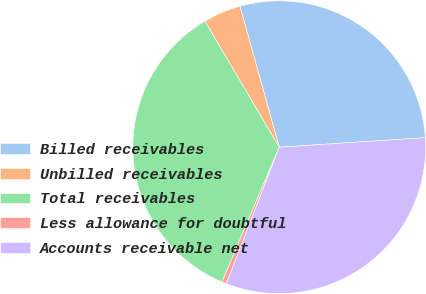Convert chart to OTSL. <chart><loc_0><loc_0><loc_500><loc_500><pie_chart><fcel>Billed receivables<fcel>Unbilled receivables<fcel>Total receivables<fcel>Less allowance for doubtful<fcel>Accounts receivable net<nl><fcel>28.28%<fcel>4.16%<fcel>35.12%<fcel>0.51%<fcel>31.93%<nl></chart> 